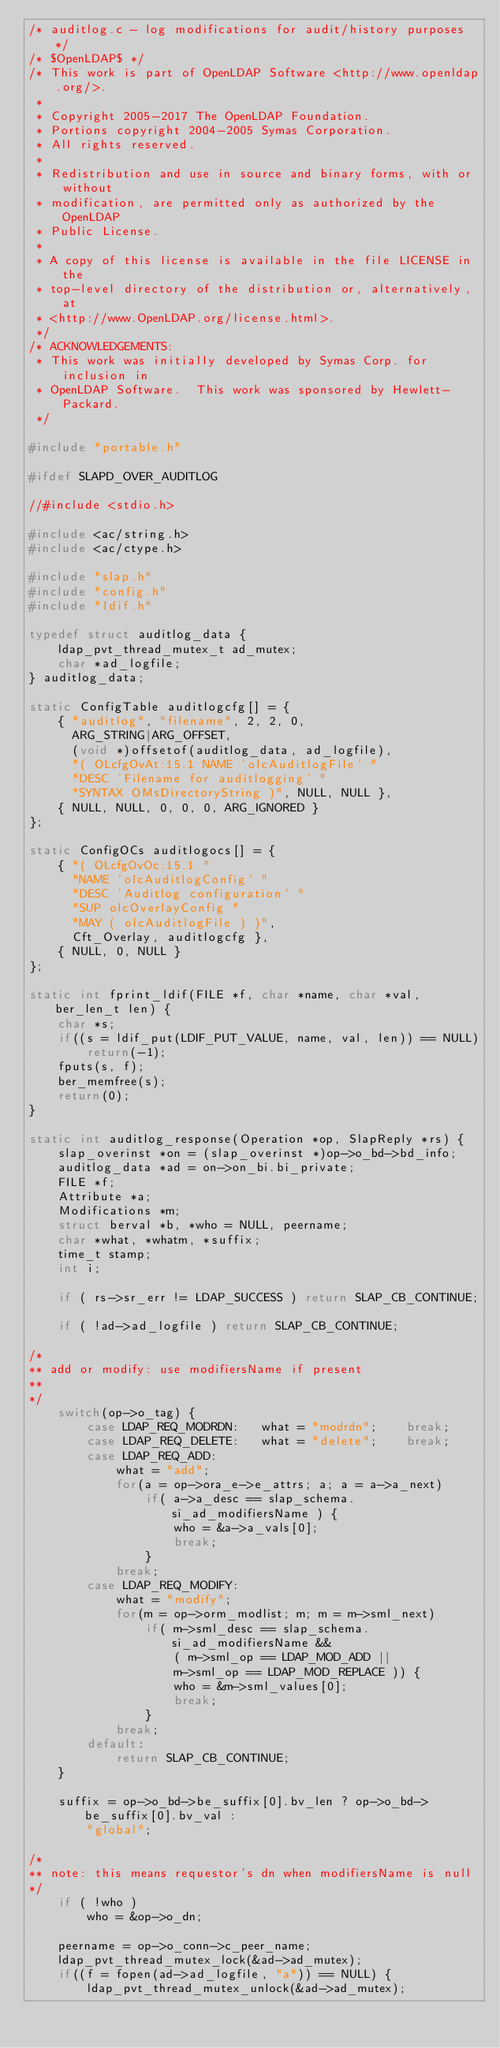<code> <loc_0><loc_0><loc_500><loc_500><_C_>/* auditlog.c - log modifications for audit/history purposes */
/* $OpenLDAP$ */
/* This work is part of OpenLDAP Software <http://www.openldap.org/>.
 *
 * Copyright 2005-2017 The OpenLDAP Foundation.
 * Portions copyright 2004-2005 Symas Corporation.
 * All rights reserved.
 *
 * Redistribution and use in source and binary forms, with or without
 * modification, are permitted only as authorized by the OpenLDAP
 * Public License.
 *
 * A copy of this license is available in the file LICENSE in the
 * top-level directory of the distribution or, alternatively, at
 * <http://www.OpenLDAP.org/license.html>.
 */
/* ACKNOWLEDGEMENTS:
 * This work was initially developed by Symas Corp. for inclusion in
 * OpenLDAP Software.  This work was sponsored by Hewlett-Packard.
 */

#include "portable.h"

#ifdef SLAPD_OVER_AUDITLOG

//#include <stdio.h>

#include <ac/string.h>
#include <ac/ctype.h>

#include "slap.h"
#include "config.h"
#include "ldif.h"

typedef struct auditlog_data {
	ldap_pvt_thread_mutex_t ad_mutex;
	char *ad_logfile;
} auditlog_data;

static ConfigTable auditlogcfg[] = {
	{ "auditlog", "filename", 2, 2, 0,
	  ARG_STRING|ARG_OFFSET,
	  (void *)offsetof(auditlog_data, ad_logfile),
	  "( OLcfgOvAt:15.1 NAME 'olcAuditlogFile' "
	  "DESC 'Filename for auditlogging' "
	  "SYNTAX OMsDirectoryString )", NULL, NULL },
	{ NULL, NULL, 0, 0, 0, ARG_IGNORED }
};

static ConfigOCs auditlogocs[] = {
	{ "( OLcfgOvOc:15.1 "
	  "NAME 'olcAuditlogConfig' "
	  "DESC 'Auditlog configuration' "
	  "SUP olcOverlayConfig "
	  "MAY ( olcAuditlogFile ) )",
	  Cft_Overlay, auditlogcfg },
	{ NULL, 0, NULL }
};

static int fprint_ldif(FILE *f, char *name, char *val, ber_len_t len) {
	char *s;
	if((s = ldif_put(LDIF_PUT_VALUE, name, val, len)) == NULL)
		return(-1);
	fputs(s, f);
	ber_memfree(s);
	return(0);
}

static int auditlog_response(Operation *op, SlapReply *rs) {
	slap_overinst *on = (slap_overinst *)op->o_bd->bd_info;
	auditlog_data *ad = on->on_bi.bi_private;
	FILE *f;
	Attribute *a;
	Modifications *m;
	struct berval *b, *who = NULL, peername;
	char *what, *whatm, *suffix;
	time_t stamp;
	int i;

	if ( rs->sr_err != LDAP_SUCCESS ) return SLAP_CB_CONTINUE;

	if ( !ad->ad_logfile ) return SLAP_CB_CONTINUE;

/*
** add or modify: use modifiersName if present
**
*/
	switch(op->o_tag) {
		case LDAP_REQ_MODRDN:	what = "modrdn";	break;
		case LDAP_REQ_DELETE:	what = "delete";	break;
		case LDAP_REQ_ADD:
			what = "add";
			for(a = op->ora_e->e_attrs; a; a = a->a_next)
				if( a->a_desc == slap_schema.si_ad_modifiersName ) {
					who = &a->a_vals[0];
					break;
				}
			break;
		case LDAP_REQ_MODIFY:
			what = "modify";
			for(m = op->orm_modlist; m; m = m->sml_next)
				if( m->sml_desc == slap_schema.si_ad_modifiersName &&
					( m->sml_op == LDAP_MOD_ADD ||
					m->sml_op == LDAP_MOD_REPLACE )) {
					who = &m->sml_values[0];
					break;
				}
			break;
		default:
			return SLAP_CB_CONTINUE;
	}

	suffix = op->o_bd->be_suffix[0].bv_len ? op->o_bd->be_suffix[0].bv_val :
		"global";

/*
** note: this means requestor's dn when modifiersName is null
*/
	if ( !who )
		who = &op->o_dn;

	peername = op->o_conn->c_peer_name;
	ldap_pvt_thread_mutex_lock(&ad->ad_mutex);
	if((f = fopen(ad->ad_logfile, "a")) == NULL) {
		ldap_pvt_thread_mutex_unlock(&ad->ad_mutex);</code> 